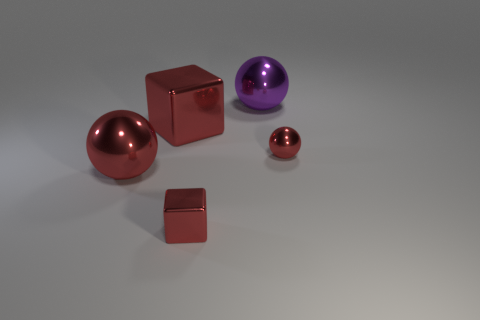Is there a brown thing that has the same material as the purple thing?
Offer a terse response. No. The other ball that is the same color as the tiny metallic ball is what size?
Keep it short and to the point. Large. What is the color of the cube that is in front of the red shiny ball to the right of the purple shiny object?
Make the answer very short. Red. How many cubes are either cyan rubber things or big metallic things?
Ensure brevity in your answer.  1. What number of small metallic balls are behind the small red metallic cube in front of the big red shiny sphere?
Make the answer very short. 1. What shape is the small thing that is to the right of the small thing in front of the tiny red sphere?
Offer a terse response. Sphere. What is the size of the purple object?
Make the answer very short. Large. The big purple metal thing is what shape?
Make the answer very short. Sphere. Is the shape of the large purple metal thing the same as the big red thing that is behind the big red metallic ball?
Provide a short and direct response. No. There is a tiny red metal object that is behind the tiny red shiny block; does it have the same shape as the purple object?
Ensure brevity in your answer.  Yes. 